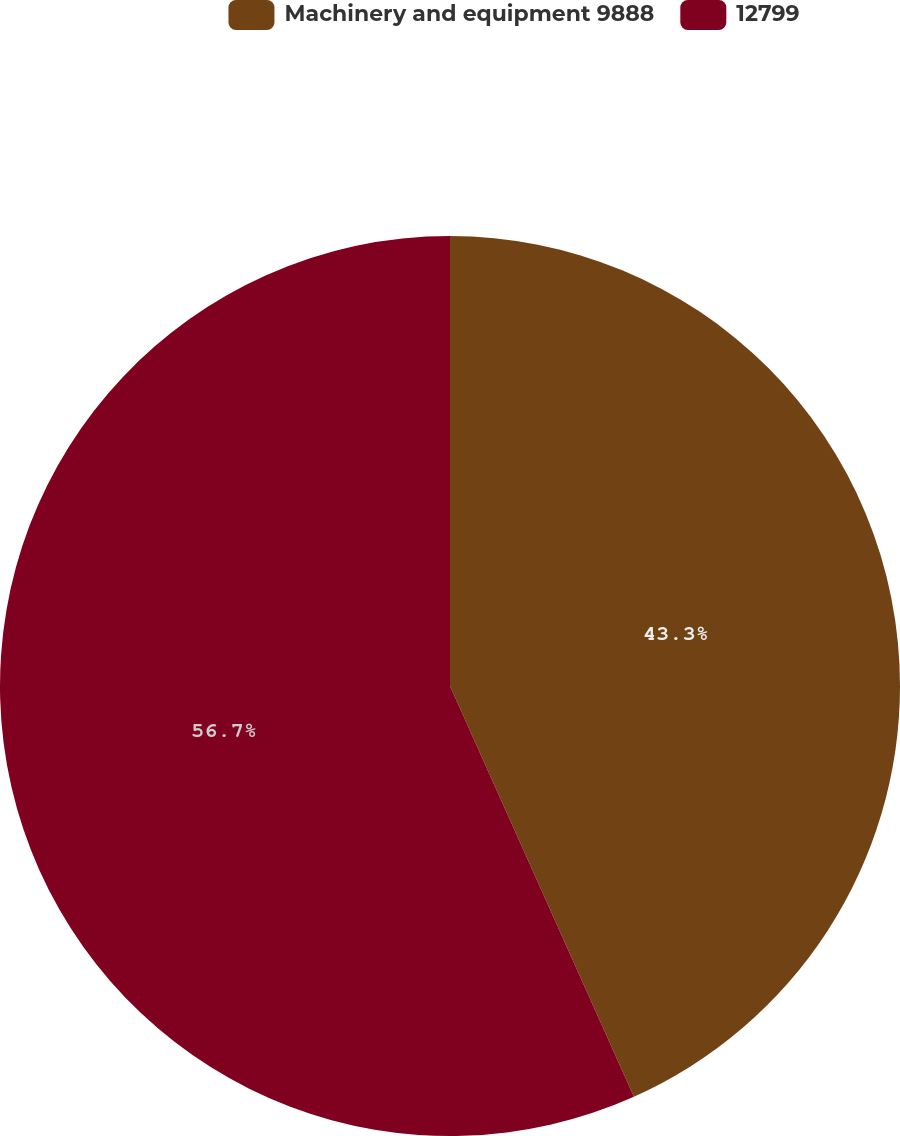Convert chart. <chart><loc_0><loc_0><loc_500><loc_500><pie_chart><fcel>Machinery and equipment 9888<fcel>12799<nl><fcel>43.3%<fcel>56.7%<nl></chart> 